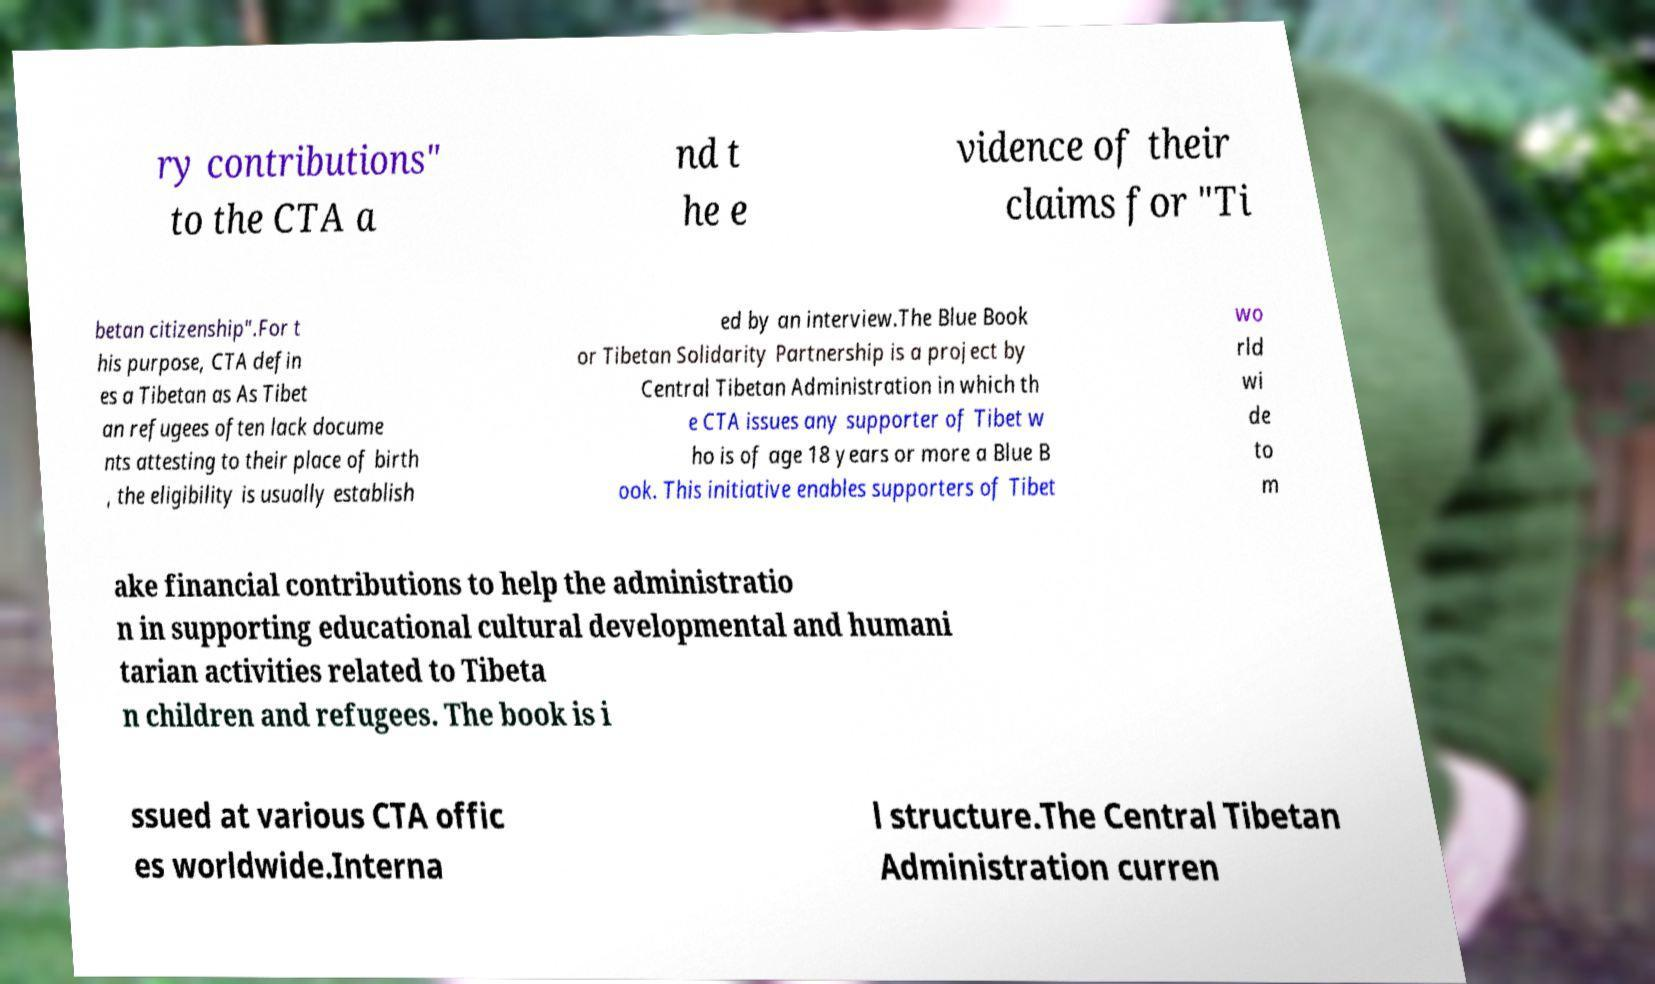Please read and relay the text visible in this image. What does it say? ry contributions" to the CTA a nd t he e vidence of their claims for "Ti betan citizenship".For t his purpose, CTA defin es a Tibetan as As Tibet an refugees often lack docume nts attesting to their place of birth , the eligibility is usually establish ed by an interview.The Blue Book or Tibetan Solidarity Partnership is a project by Central Tibetan Administration in which th e CTA issues any supporter of Tibet w ho is of age 18 years or more a Blue B ook. This initiative enables supporters of Tibet wo rld wi de to m ake financial contributions to help the administratio n in supporting educational cultural developmental and humani tarian activities related to Tibeta n children and refugees. The book is i ssued at various CTA offic es worldwide.Interna l structure.The Central Tibetan Administration curren 